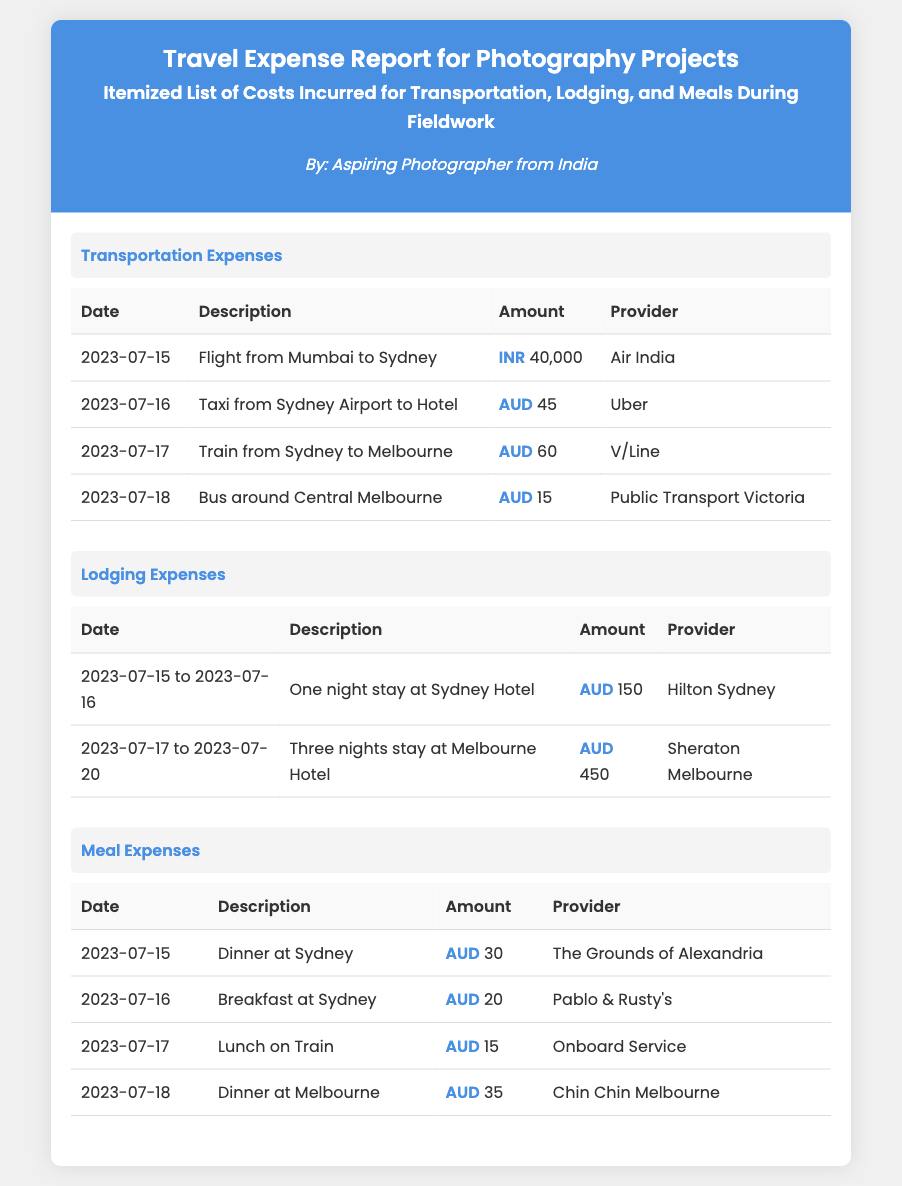What was the flight cost from Mumbai to Sydney? The flight cost from Mumbai to Sydney is listed as INR 40,000.
Answer: INR 40,000 How many nights was the stay at the Melbourne Hotel? The stay at the Melbourne Hotel lasted for three nights, from July 17 to July 20.
Answer: Three nights What was the total meal expense on July 16? The total meal expense on July 16 includes breakfast at AUD 20 and no other meals listed, making it AUD 20.
Answer: AUD 20 Which provider did the lunch on the train come from? The provider for the lunch on the train is listed as Onboard Service.
Answer: Onboard Service What is the cost of taxi service from Sydney Airport to Hotel? The cost of the taxi service from Sydney Airport to Hotel is listed as AUD 45.
Answer: AUD 45 What type of document is this? This document is a travel expense report.
Answer: Travel expense report How many meals are listed in the meal expenses section? There are four meals listed in the meal expenses section of the document.
Answer: Four meals Which hotel provided lodging for the stay from July 15 to July 16? The hotel that provided lodging for that date is Hilton Sydney.
Answer: Hilton Sydney What is the total lodging expense incurred? The total lodging expense is AUD 150 for Sydney Hotel plus AUD 450 for Melbourne Hotel, totaling AUD 600.
Answer: AUD 600 